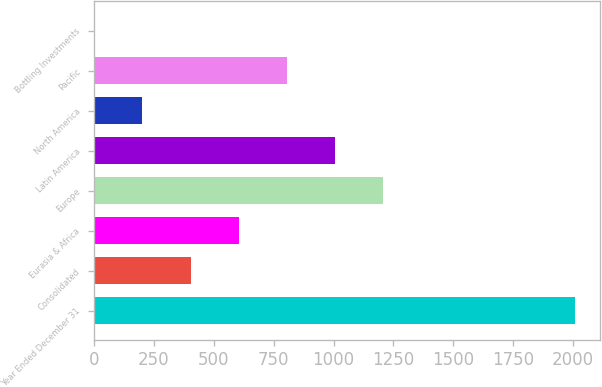Convert chart. <chart><loc_0><loc_0><loc_500><loc_500><bar_chart><fcel>Year Ended December 31<fcel>Consolidated<fcel>Eurasia & Africa<fcel>Europe<fcel>Latin America<fcel>North America<fcel>Pacific<fcel>Bottling Investments<nl><fcel>2009<fcel>403.56<fcel>604.24<fcel>1206.28<fcel>1005.6<fcel>202.88<fcel>804.92<fcel>2.2<nl></chart> 